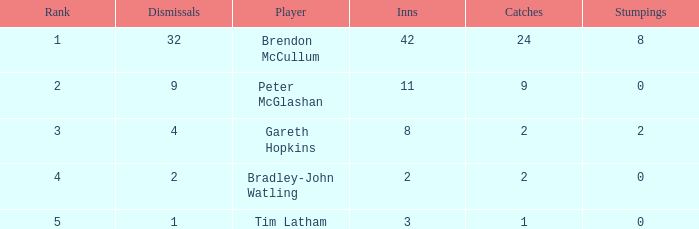Would you mind parsing the complete table? {'header': ['Rank', 'Dismissals', 'Player', 'Inns', 'Catches', 'Stumpings'], 'rows': [['1', '32', 'Brendon McCullum', '42', '24', '8'], ['2', '9', 'Peter McGlashan', '11', '9', '0'], ['3', '4', 'Gareth Hopkins', '8', '2', '2'], ['4', '2', 'Bradley-John Watling', '2', '2', '0'], ['5', '1', 'Tim Latham', '3', '1', '0']]} How many innings had a total of 2 catches and 0 stumpings? 1.0. 